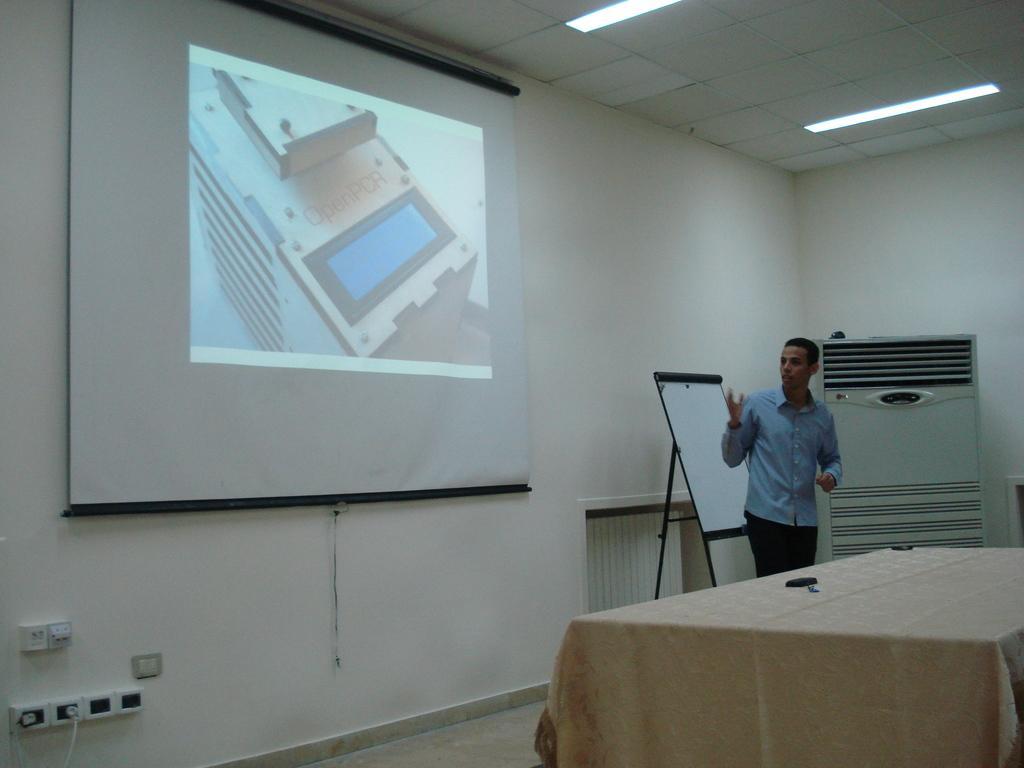Could you give a brief overview of what you see in this image? In this picture I can see a person standing on the surface. I can see projector screen. I can see the board on the right side. I can see electric switches on the left side. I can see light arrangements on the roof. I can see the table. 